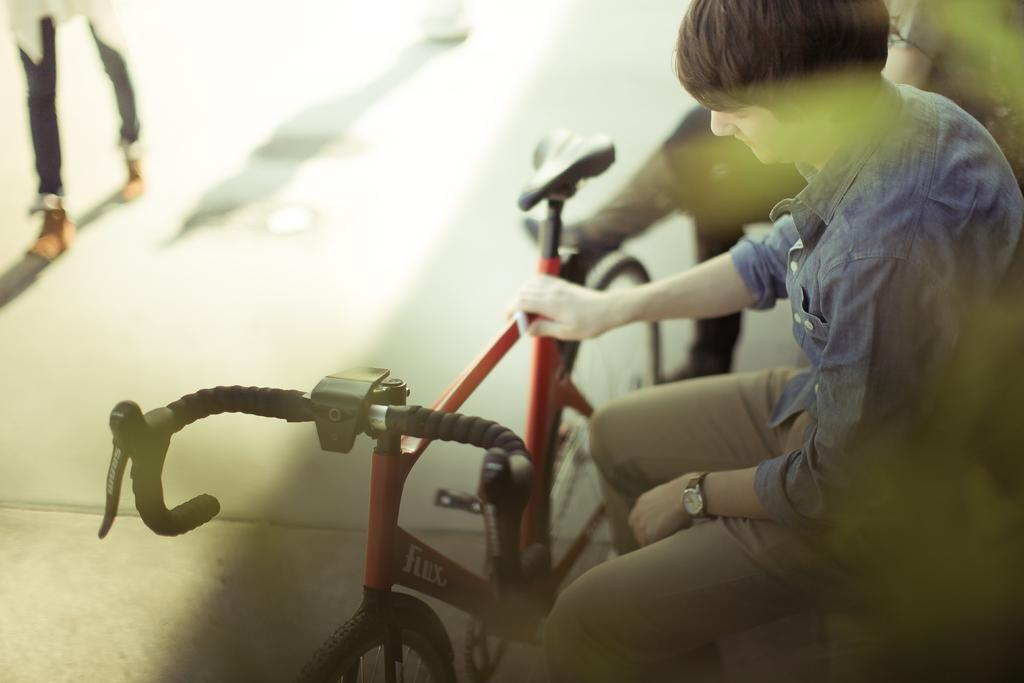How many people are sitting in the image? There are two people sitting in the image. What can be seen on the ground in the image? There is a bicycle on the ground in the image. Can you describe any other visible body parts besides the people sitting? Yes, there are person's legs visible in the background of the image. What type of butter is being used to caption the image? There is no butter or caption present in the image. How many buns are visible in the image? There are no buns visible in the image. 